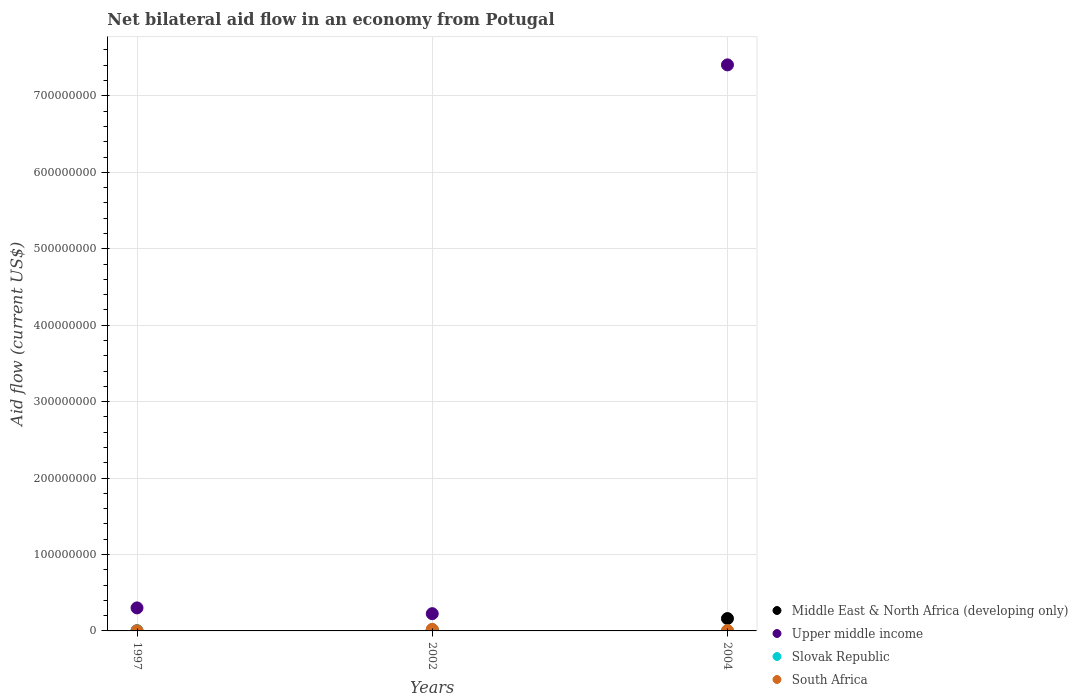Is the number of dotlines equal to the number of legend labels?
Make the answer very short. Yes. What is the net bilateral aid flow in South Africa in 2002?
Keep it short and to the point. 2.01e+06. In which year was the net bilateral aid flow in South Africa maximum?
Provide a succinct answer. 2002. What is the total net bilateral aid flow in Upper middle income in the graph?
Provide a succinct answer. 7.93e+08. What is the difference between the net bilateral aid flow in South Africa in 2002 and that in 2004?
Provide a short and direct response. 1.61e+06. What is the average net bilateral aid flow in Middle East & North Africa (developing only) per year?
Your answer should be compact. 5.86e+06. In the year 2002, what is the difference between the net bilateral aid flow in Slovak Republic and net bilateral aid flow in Middle East & North Africa (developing only)?
Provide a short and direct response. -1.25e+06. What is the ratio of the net bilateral aid flow in Middle East & North Africa (developing only) in 1997 to that in 2002?
Make the answer very short. 0.1. Is the difference between the net bilateral aid flow in Slovak Republic in 1997 and 2002 greater than the difference between the net bilateral aid flow in Middle East & North Africa (developing only) in 1997 and 2002?
Your answer should be compact. Yes. Is the sum of the net bilateral aid flow in Slovak Republic in 2002 and 2004 greater than the maximum net bilateral aid flow in Upper middle income across all years?
Provide a succinct answer. No. Is it the case that in every year, the sum of the net bilateral aid flow in Upper middle income and net bilateral aid flow in Middle East & North Africa (developing only)  is greater than the net bilateral aid flow in South Africa?
Keep it short and to the point. Yes. Does the net bilateral aid flow in Upper middle income monotonically increase over the years?
Provide a succinct answer. No. Is the net bilateral aid flow in South Africa strictly greater than the net bilateral aid flow in Middle East & North Africa (developing only) over the years?
Provide a short and direct response. No. Is the net bilateral aid flow in Middle East & North Africa (developing only) strictly less than the net bilateral aid flow in Upper middle income over the years?
Give a very brief answer. Yes. How many dotlines are there?
Your answer should be very brief. 4. How many years are there in the graph?
Your response must be concise. 3. What is the difference between two consecutive major ticks on the Y-axis?
Your response must be concise. 1.00e+08. Does the graph contain any zero values?
Ensure brevity in your answer.  No. Where does the legend appear in the graph?
Keep it short and to the point. Bottom right. How are the legend labels stacked?
Give a very brief answer. Vertical. What is the title of the graph?
Keep it short and to the point. Net bilateral aid flow in an economy from Potugal. Does "Small states" appear as one of the legend labels in the graph?
Ensure brevity in your answer.  No. What is the Aid flow (current US$) in Middle East & North Africa (developing only) in 1997?
Provide a succinct answer. 1.30e+05. What is the Aid flow (current US$) in Upper middle income in 1997?
Keep it short and to the point. 3.01e+07. What is the Aid flow (current US$) of Slovak Republic in 1997?
Ensure brevity in your answer.  10000. What is the Aid flow (current US$) in Middle East & North Africa (developing only) in 2002?
Offer a very short reply. 1.26e+06. What is the Aid flow (current US$) of Upper middle income in 2002?
Provide a short and direct response. 2.26e+07. What is the Aid flow (current US$) of South Africa in 2002?
Your answer should be very brief. 2.01e+06. What is the Aid flow (current US$) in Middle East & North Africa (developing only) in 2004?
Provide a short and direct response. 1.62e+07. What is the Aid flow (current US$) of Upper middle income in 2004?
Give a very brief answer. 7.41e+08. Across all years, what is the maximum Aid flow (current US$) in Middle East & North Africa (developing only)?
Your response must be concise. 1.62e+07. Across all years, what is the maximum Aid flow (current US$) in Upper middle income?
Make the answer very short. 7.41e+08. Across all years, what is the maximum Aid flow (current US$) in Slovak Republic?
Give a very brief answer. 10000. Across all years, what is the maximum Aid flow (current US$) in South Africa?
Give a very brief answer. 2.01e+06. Across all years, what is the minimum Aid flow (current US$) of Middle East & North Africa (developing only)?
Keep it short and to the point. 1.30e+05. Across all years, what is the minimum Aid flow (current US$) in Upper middle income?
Offer a terse response. 2.26e+07. Across all years, what is the minimum Aid flow (current US$) of Slovak Republic?
Your answer should be compact. 10000. What is the total Aid flow (current US$) in Middle East & North Africa (developing only) in the graph?
Provide a short and direct response. 1.76e+07. What is the total Aid flow (current US$) in Upper middle income in the graph?
Keep it short and to the point. 7.93e+08. What is the total Aid flow (current US$) of Slovak Republic in the graph?
Offer a very short reply. 3.00e+04. What is the total Aid flow (current US$) in South Africa in the graph?
Provide a short and direct response. 2.45e+06. What is the difference between the Aid flow (current US$) of Middle East & North Africa (developing only) in 1997 and that in 2002?
Make the answer very short. -1.13e+06. What is the difference between the Aid flow (current US$) in Upper middle income in 1997 and that in 2002?
Your response must be concise. 7.55e+06. What is the difference between the Aid flow (current US$) in South Africa in 1997 and that in 2002?
Provide a short and direct response. -1.97e+06. What is the difference between the Aid flow (current US$) of Middle East & North Africa (developing only) in 1997 and that in 2004?
Give a very brief answer. -1.60e+07. What is the difference between the Aid flow (current US$) in Upper middle income in 1997 and that in 2004?
Your answer should be very brief. -7.10e+08. What is the difference between the Aid flow (current US$) in South Africa in 1997 and that in 2004?
Provide a succinct answer. -3.60e+05. What is the difference between the Aid flow (current US$) in Middle East & North Africa (developing only) in 2002 and that in 2004?
Make the answer very short. -1.49e+07. What is the difference between the Aid flow (current US$) in Upper middle income in 2002 and that in 2004?
Make the answer very short. -7.18e+08. What is the difference between the Aid flow (current US$) in South Africa in 2002 and that in 2004?
Keep it short and to the point. 1.61e+06. What is the difference between the Aid flow (current US$) of Middle East & North Africa (developing only) in 1997 and the Aid flow (current US$) of Upper middle income in 2002?
Your answer should be very brief. -2.24e+07. What is the difference between the Aid flow (current US$) of Middle East & North Africa (developing only) in 1997 and the Aid flow (current US$) of South Africa in 2002?
Your answer should be very brief. -1.88e+06. What is the difference between the Aid flow (current US$) in Upper middle income in 1997 and the Aid flow (current US$) in Slovak Republic in 2002?
Keep it short and to the point. 3.01e+07. What is the difference between the Aid flow (current US$) of Upper middle income in 1997 and the Aid flow (current US$) of South Africa in 2002?
Offer a very short reply. 2.81e+07. What is the difference between the Aid flow (current US$) in Middle East & North Africa (developing only) in 1997 and the Aid flow (current US$) in Upper middle income in 2004?
Make the answer very short. -7.40e+08. What is the difference between the Aid flow (current US$) of Middle East & North Africa (developing only) in 1997 and the Aid flow (current US$) of South Africa in 2004?
Offer a terse response. -2.70e+05. What is the difference between the Aid flow (current US$) in Upper middle income in 1997 and the Aid flow (current US$) in Slovak Republic in 2004?
Offer a very short reply. 3.01e+07. What is the difference between the Aid flow (current US$) of Upper middle income in 1997 and the Aid flow (current US$) of South Africa in 2004?
Ensure brevity in your answer.  2.97e+07. What is the difference between the Aid flow (current US$) of Slovak Republic in 1997 and the Aid flow (current US$) of South Africa in 2004?
Offer a terse response. -3.90e+05. What is the difference between the Aid flow (current US$) of Middle East & North Africa (developing only) in 2002 and the Aid flow (current US$) of Upper middle income in 2004?
Your answer should be very brief. -7.39e+08. What is the difference between the Aid flow (current US$) of Middle East & North Africa (developing only) in 2002 and the Aid flow (current US$) of Slovak Republic in 2004?
Your answer should be compact. 1.25e+06. What is the difference between the Aid flow (current US$) of Middle East & North Africa (developing only) in 2002 and the Aid flow (current US$) of South Africa in 2004?
Your answer should be very brief. 8.60e+05. What is the difference between the Aid flow (current US$) of Upper middle income in 2002 and the Aid flow (current US$) of Slovak Republic in 2004?
Your response must be concise. 2.26e+07. What is the difference between the Aid flow (current US$) in Upper middle income in 2002 and the Aid flow (current US$) in South Africa in 2004?
Offer a terse response. 2.22e+07. What is the difference between the Aid flow (current US$) of Slovak Republic in 2002 and the Aid flow (current US$) of South Africa in 2004?
Provide a short and direct response. -3.90e+05. What is the average Aid flow (current US$) in Middle East & North Africa (developing only) per year?
Provide a succinct answer. 5.86e+06. What is the average Aid flow (current US$) in Upper middle income per year?
Ensure brevity in your answer.  2.64e+08. What is the average Aid flow (current US$) in South Africa per year?
Ensure brevity in your answer.  8.17e+05. In the year 1997, what is the difference between the Aid flow (current US$) of Middle East & North Africa (developing only) and Aid flow (current US$) of Upper middle income?
Give a very brief answer. -3.00e+07. In the year 1997, what is the difference between the Aid flow (current US$) in Middle East & North Africa (developing only) and Aid flow (current US$) in Slovak Republic?
Make the answer very short. 1.20e+05. In the year 1997, what is the difference between the Aid flow (current US$) in Middle East & North Africa (developing only) and Aid flow (current US$) in South Africa?
Keep it short and to the point. 9.00e+04. In the year 1997, what is the difference between the Aid flow (current US$) of Upper middle income and Aid flow (current US$) of Slovak Republic?
Your answer should be compact. 3.01e+07. In the year 1997, what is the difference between the Aid flow (current US$) of Upper middle income and Aid flow (current US$) of South Africa?
Give a very brief answer. 3.01e+07. In the year 1997, what is the difference between the Aid flow (current US$) in Slovak Republic and Aid flow (current US$) in South Africa?
Provide a short and direct response. -3.00e+04. In the year 2002, what is the difference between the Aid flow (current US$) in Middle East & North Africa (developing only) and Aid flow (current US$) in Upper middle income?
Provide a short and direct response. -2.13e+07. In the year 2002, what is the difference between the Aid flow (current US$) of Middle East & North Africa (developing only) and Aid flow (current US$) of Slovak Republic?
Make the answer very short. 1.25e+06. In the year 2002, what is the difference between the Aid flow (current US$) of Middle East & North Africa (developing only) and Aid flow (current US$) of South Africa?
Offer a terse response. -7.50e+05. In the year 2002, what is the difference between the Aid flow (current US$) in Upper middle income and Aid flow (current US$) in Slovak Republic?
Offer a very short reply. 2.26e+07. In the year 2002, what is the difference between the Aid flow (current US$) in Upper middle income and Aid flow (current US$) in South Africa?
Provide a succinct answer. 2.06e+07. In the year 2002, what is the difference between the Aid flow (current US$) in Slovak Republic and Aid flow (current US$) in South Africa?
Keep it short and to the point. -2.00e+06. In the year 2004, what is the difference between the Aid flow (current US$) in Middle East & North Africa (developing only) and Aid flow (current US$) in Upper middle income?
Your answer should be compact. -7.24e+08. In the year 2004, what is the difference between the Aid flow (current US$) of Middle East & North Africa (developing only) and Aid flow (current US$) of Slovak Republic?
Provide a succinct answer. 1.62e+07. In the year 2004, what is the difference between the Aid flow (current US$) in Middle East & North Africa (developing only) and Aid flow (current US$) in South Africa?
Ensure brevity in your answer.  1.58e+07. In the year 2004, what is the difference between the Aid flow (current US$) of Upper middle income and Aid flow (current US$) of Slovak Republic?
Provide a succinct answer. 7.41e+08. In the year 2004, what is the difference between the Aid flow (current US$) of Upper middle income and Aid flow (current US$) of South Africa?
Provide a short and direct response. 7.40e+08. In the year 2004, what is the difference between the Aid flow (current US$) of Slovak Republic and Aid flow (current US$) of South Africa?
Ensure brevity in your answer.  -3.90e+05. What is the ratio of the Aid flow (current US$) in Middle East & North Africa (developing only) in 1997 to that in 2002?
Make the answer very short. 0.1. What is the ratio of the Aid flow (current US$) in Upper middle income in 1997 to that in 2002?
Give a very brief answer. 1.33. What is the ratio of the Aid flow (current US$) of South Africa in 1997 to that in 2002?
Provide a short and direct response. 0.02. What is the ratio of the Aid flow (current US$) of Middle East & North Africa (developing only) in 1997 to that in 2004?
Your answer should be very brief. 0.01. What is the ratio of the Aid flow (current US$) in Upper middle income in 1997 to that in 2004?
Make the answer very short. 0.04. What is the ratio of the Aid flow (current US$) of Middle East & North Africa (developing only) in 2002 to that in 2004?
Offer a terse response. 0.08. What is the ratio of the Aid flow (current US$) in Upper middle income in 2002 to that in 2004?
Give a very brief answer. 0.03. What is the ratio of the Aid flow (current US$) of Slovak Republic in 2002 to that in 2004?
Your response must be concise. 1. What is the ratio of the Aid flow (current US$) in South Africa in 2002 to that in 2004?
Your answer should be compact. 5.03. What is the difference between the highest and the second highest Aid flow (current US$) in Middle East & North Africa (developing only)?
Provide a succinct answer. 1.49e+07. What is the difference between the highest and the second highest Aid flow (current US$) in Upper middle income?
Provide a short and direct response. 7.10e+08. What is the difference between the highest and the second highest Aid flow (current US$) in Slovak Republic?
Your response must be concise. 0. What is the difference between the highest and the second highest Aid flow (current US$) in South Africa?
Ensure brevity in your answer.  1.61e+06. What is the difference between the highest and the lowest Aid flow (current US$) of Middle East & North Africa (developing only)?
Provide a short and direct response. 1.60e+07. What is the difference between the highest and the lowest Aid flow (current US$) in Upper middle income?
Offer a very short reply. 7.18e+08. What is the difference between the highest and the lowest Aid flow (current US$) in Slovak Republic?
Keep it short and to the point. 0. What is the difference between the highest and the lowest Aid flow (current US$) in South Africa?
Provide a short and direct response. 1.97e+06. 